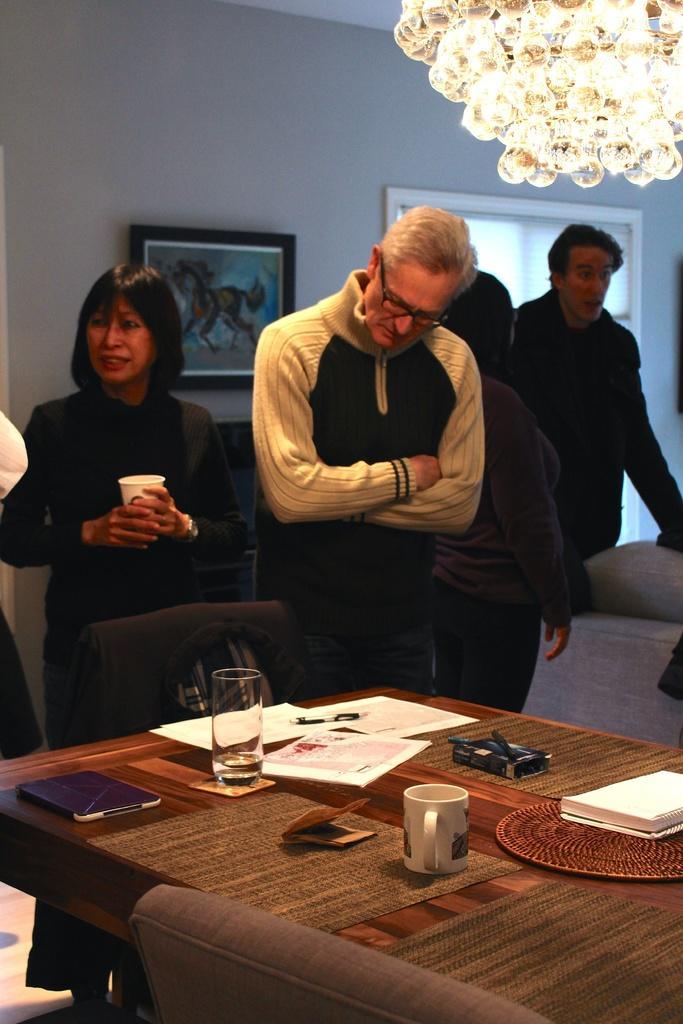Please provide a concise description of this image. In this picture we can see some persons standing on the floor. This is table. On the table there are glass, cup, and papers. And this is chair. On the background we can see a wall and this is frame. And there is a light. 